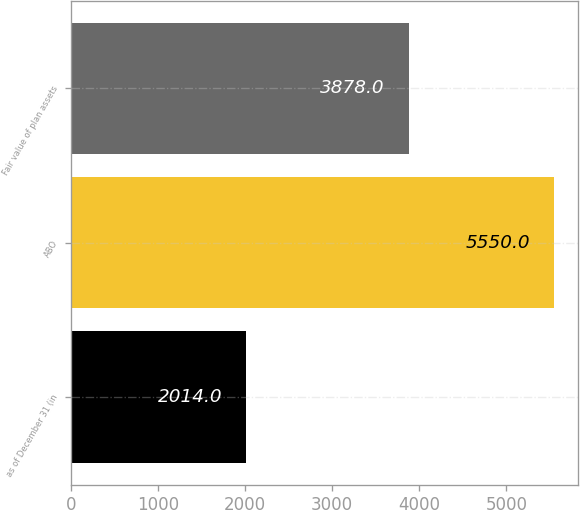Convert chart. <chart><loc_0><loc_0><loc_500><loc_500><bar_chart><fcel>as of December 31 (in<fcel>ABO<fcel>Fair value of plan assets<nl><fcel>2014<fcel>5550<fcel>3878<nl></chart> 